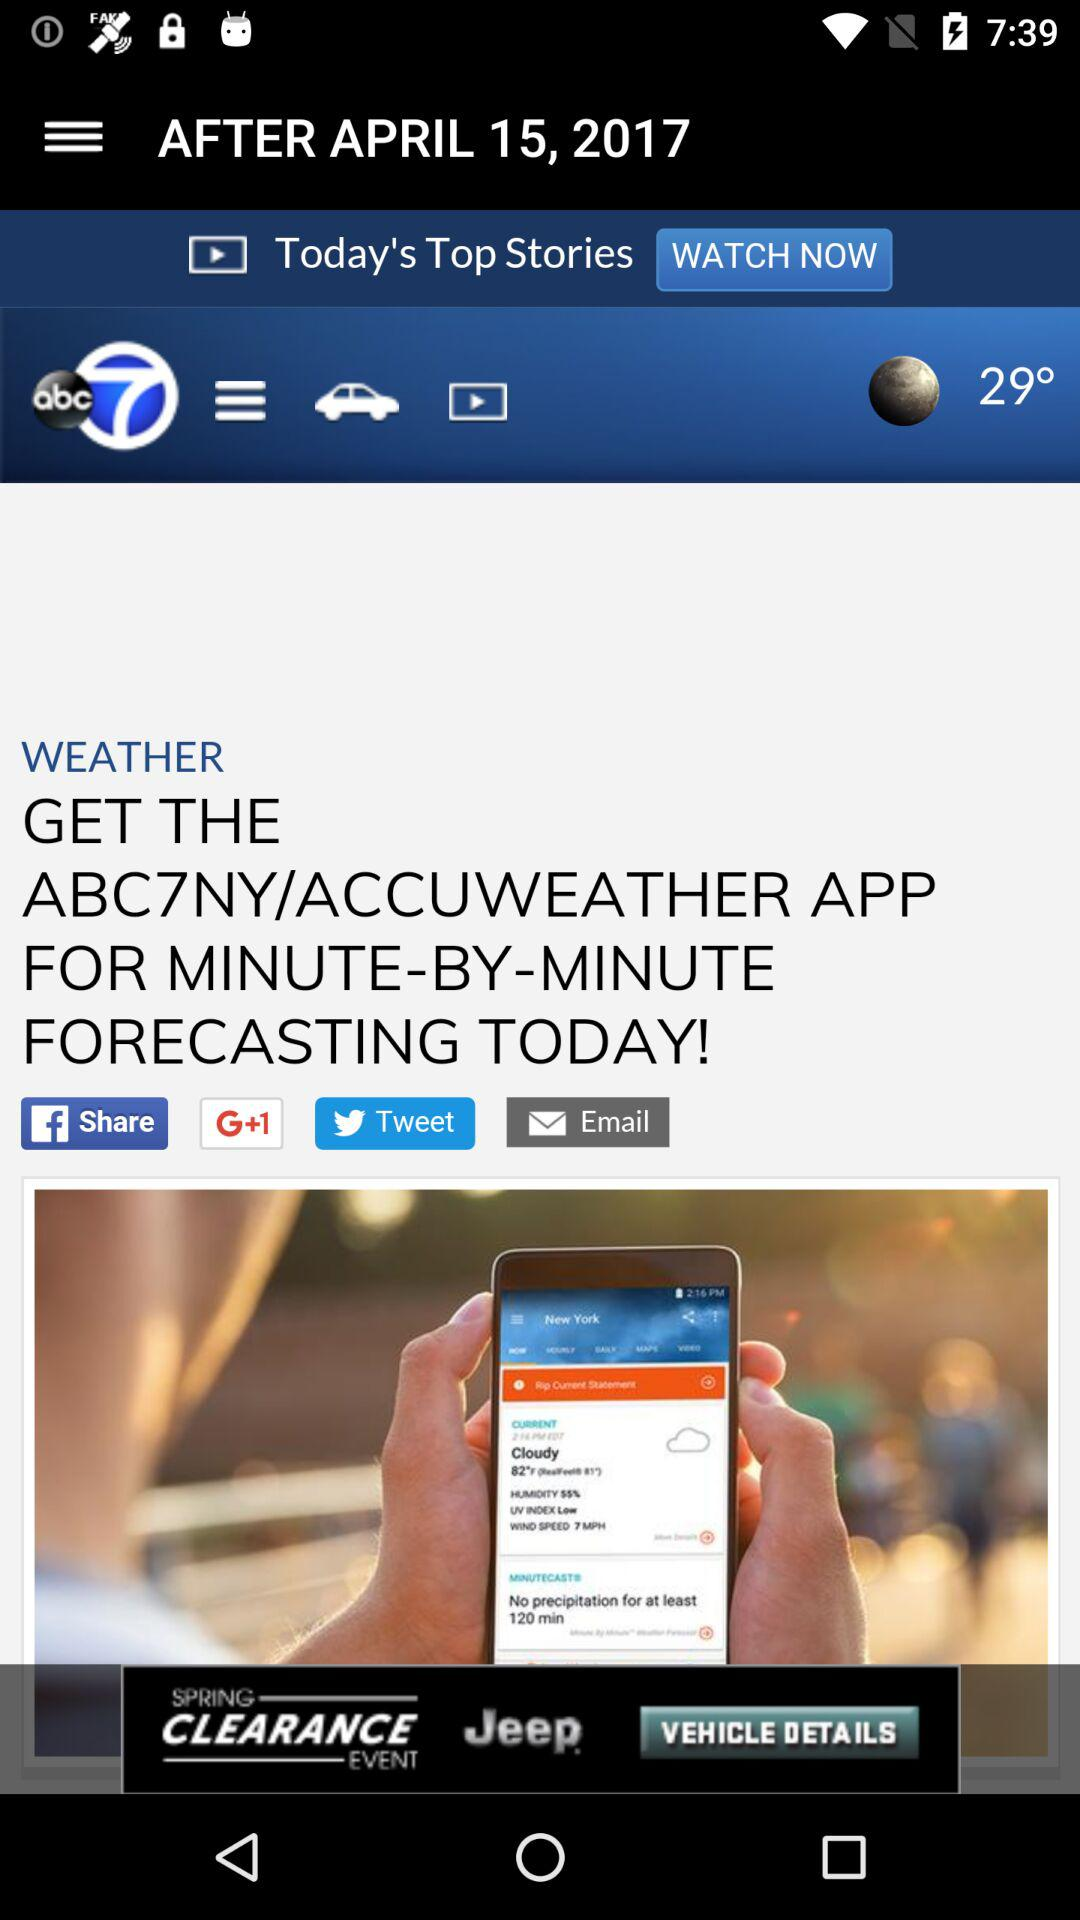How many degrees is the temperature today?
Answer the question using a single word or phrase. 29° 